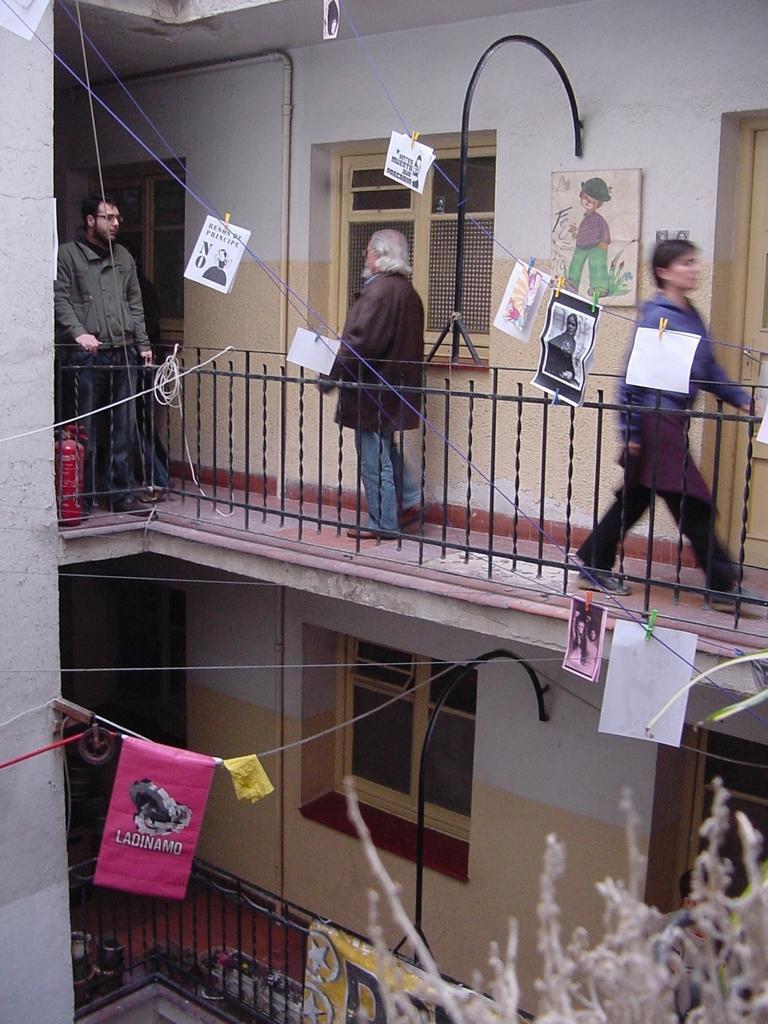Please provide a concise description of this image. In the image we can see there are people walking and some of them are standing, they are wearing clothes. We can see fence, poster, window and the door. We can see tree branches. 